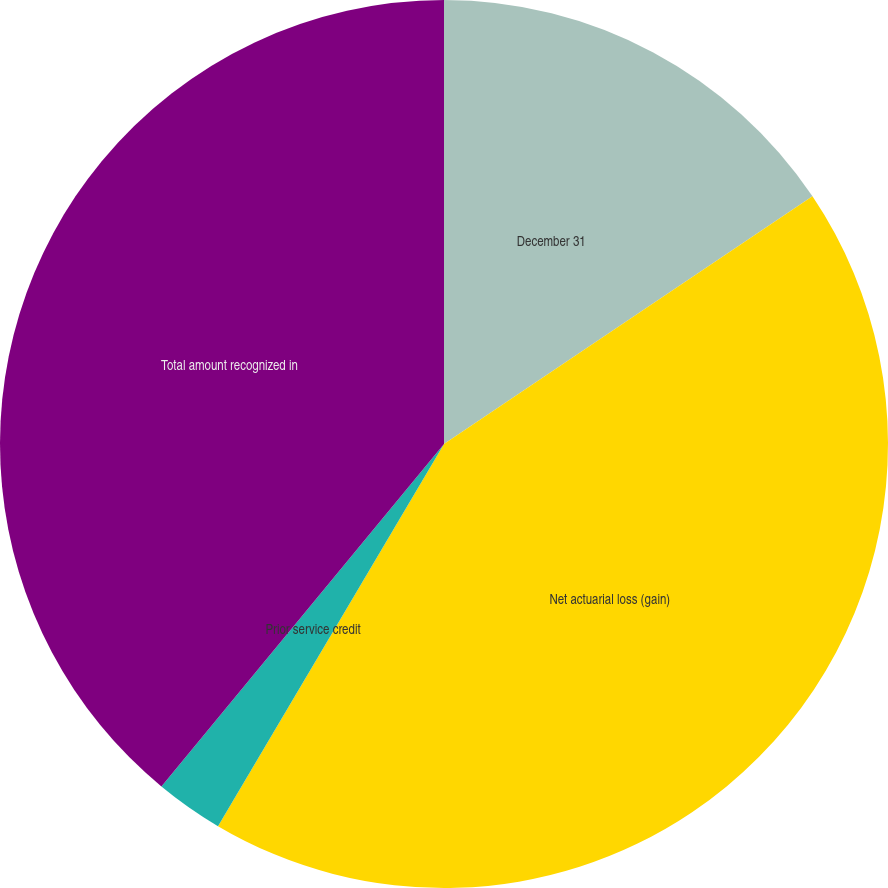<chart> <loc_0><loc_0><loc_500><loc_500><pie_chart><fcel>December 31<fcel>Net actuarial loss (gain)<fcel>Prior service credit<fcel>Total amount recognized in<nl><fcel>15.58%<fcel>42.92%<fcel>2.48%<fcel>39.02%<nl></chart> 